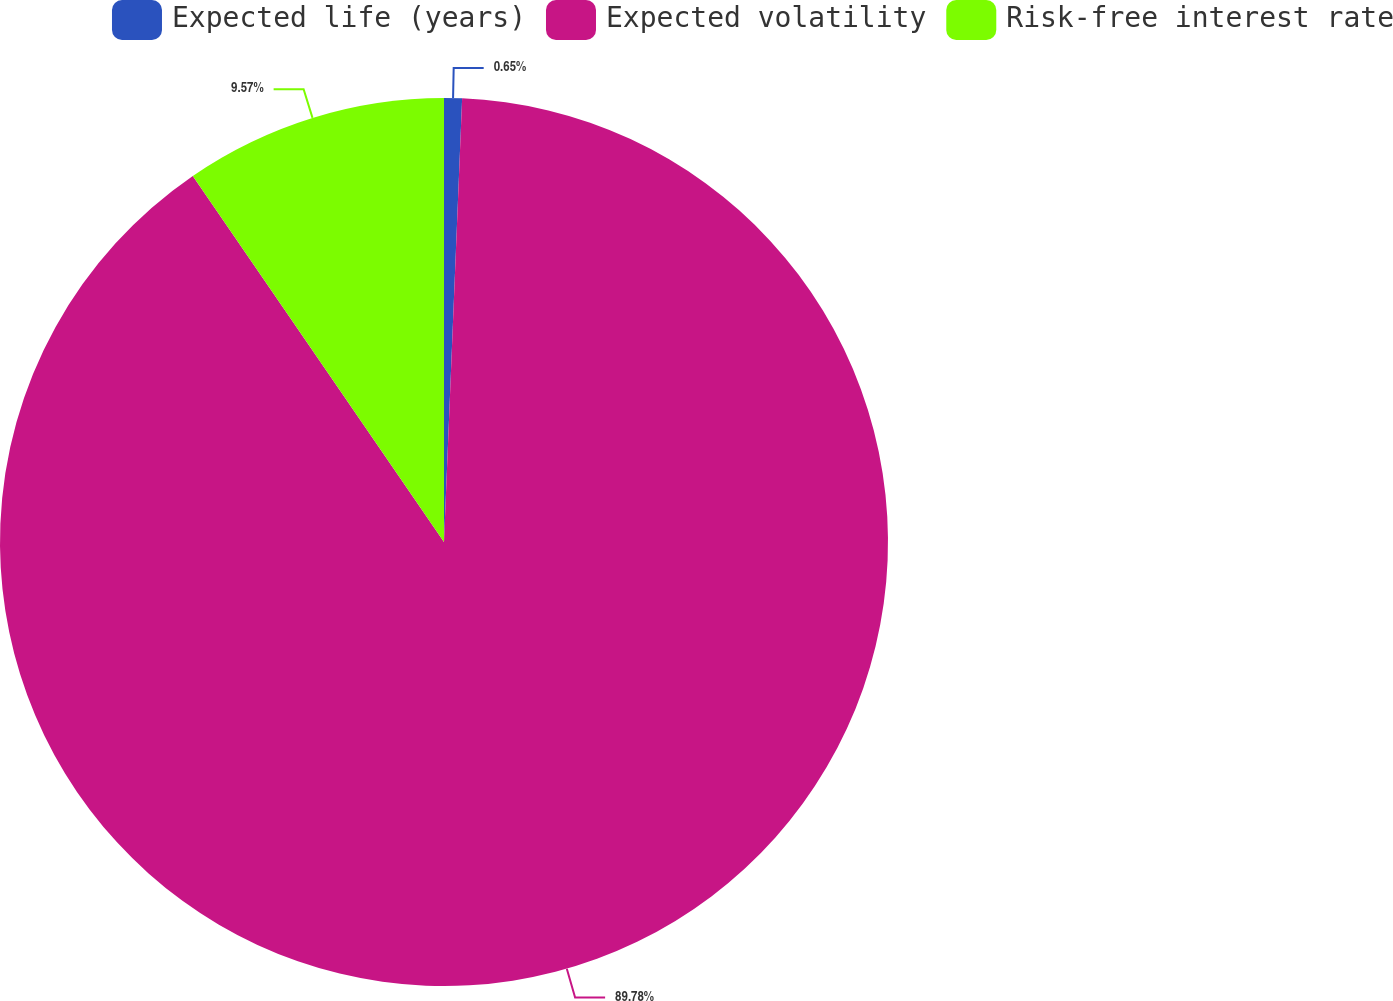Convert chart. <chart><loc_0><loc_0><loc_500><loc_500><pie_chart><fcel>Expected life (years)<fcel>Expected volatility<fcel>Risk-free interest rate<nl><fcel>0.65%<fcel>89.77%<fcel>9.57%<nl></chart> 